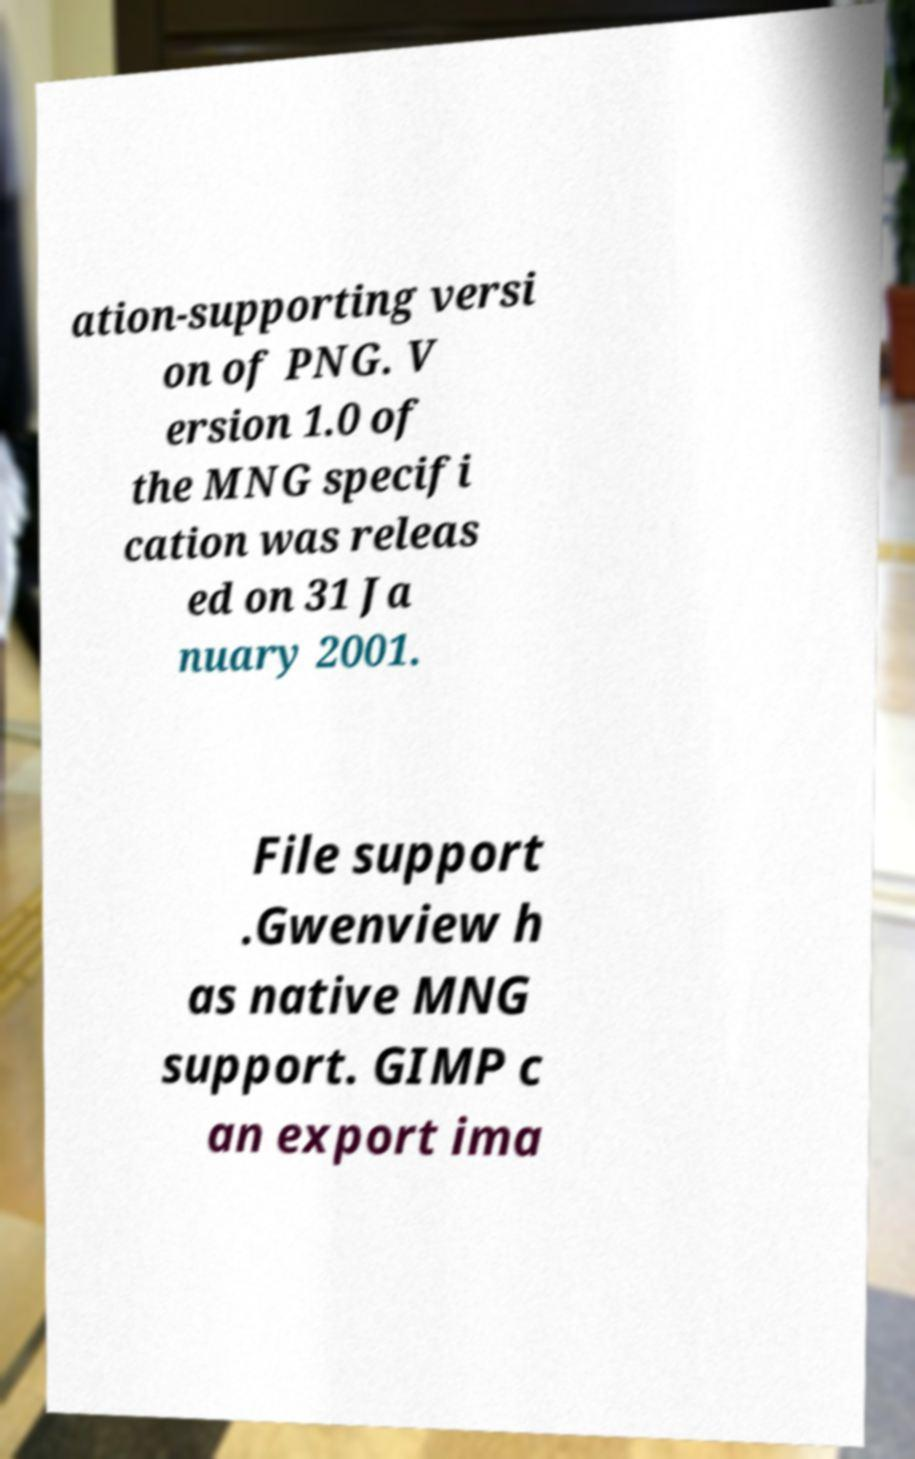There's text embedded in this image that I need extracted. Can you transcribe it verbatim? ation-supporting versi on of PNG. V ersion 1.0 of the MNG specifi cation was releas ed on 31 Ja nuary 2001. File support .Gwenview h as native MNG support. GIMP c an export ima 